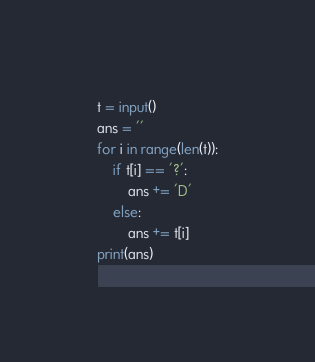Convert code to text. <code><loc_0><loc_0><loc_500><loc_500><_Python_>t = input()
ans = ''
for i in range(len(t)):
    if t[i] == '?':
        ans += 'D'
    else:
        ans += t[i]
print(ans)</code> 